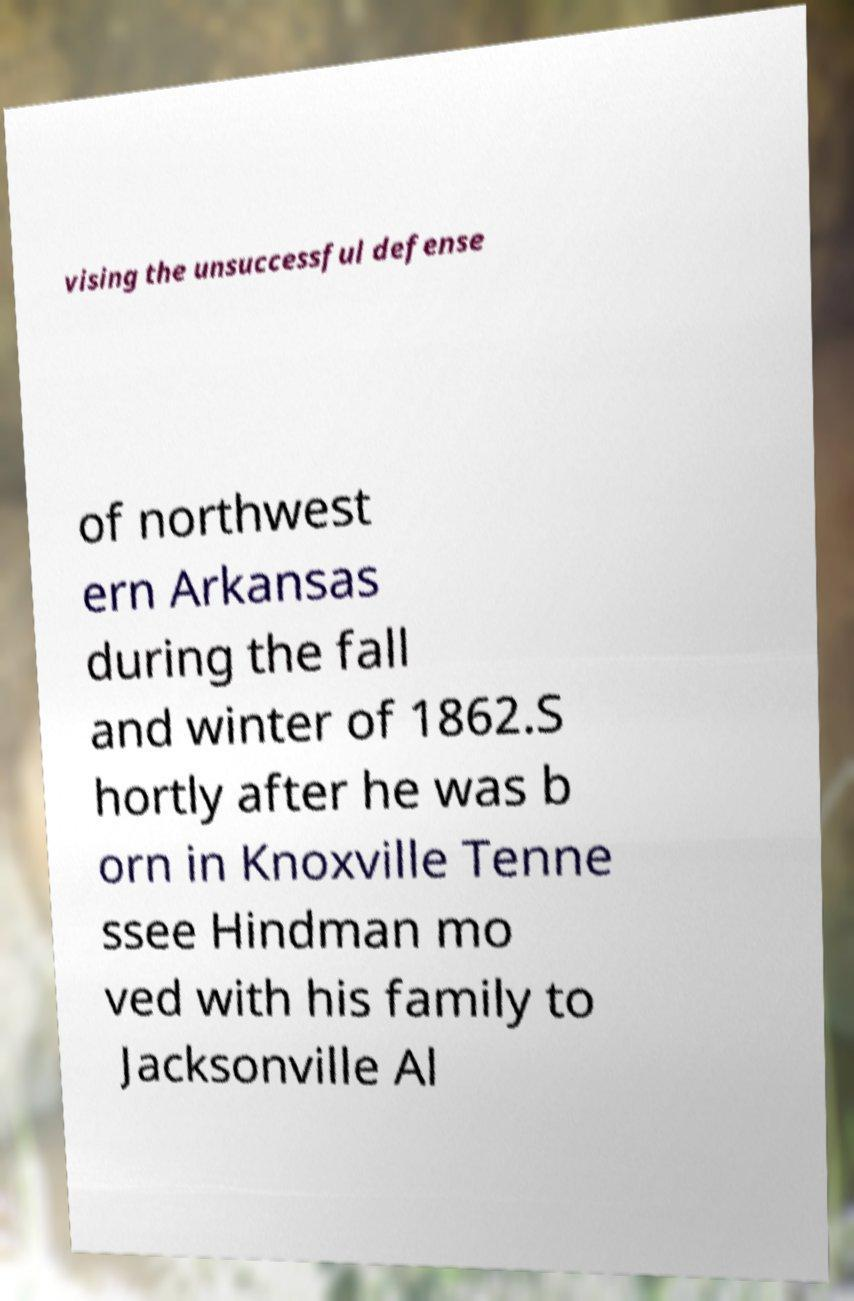Please read and relay the text visible in this image. What does it say? vising the unsuccessful defense of northwest ern Arkansas during the fall and winter of 1862.S hortly after he was b orn in Knoxville Tenne ssee Hindman mo ved with his family to Jacksonville Al 